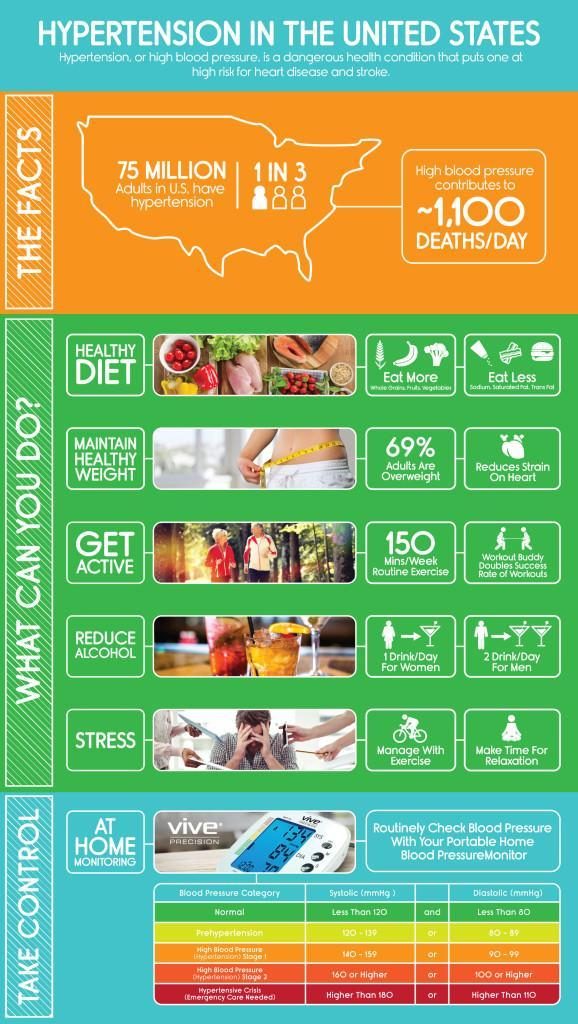What is the diastolic reading given in the third row of the table?
Answer the question with a short phrase. 90-99 What is highest reading shown in the image of blood pressure monitor 84, 134, or 70? 134 How many blood pressure categories are listed in the table ? 5 What is make of the blood pressure monitor  Dr Morepen, Vive, or HEM? Vive Precision What is the systolic reading given in the fourth row of the table? 160 or Higher How many steps can be taken to reduce hypertension? 5 